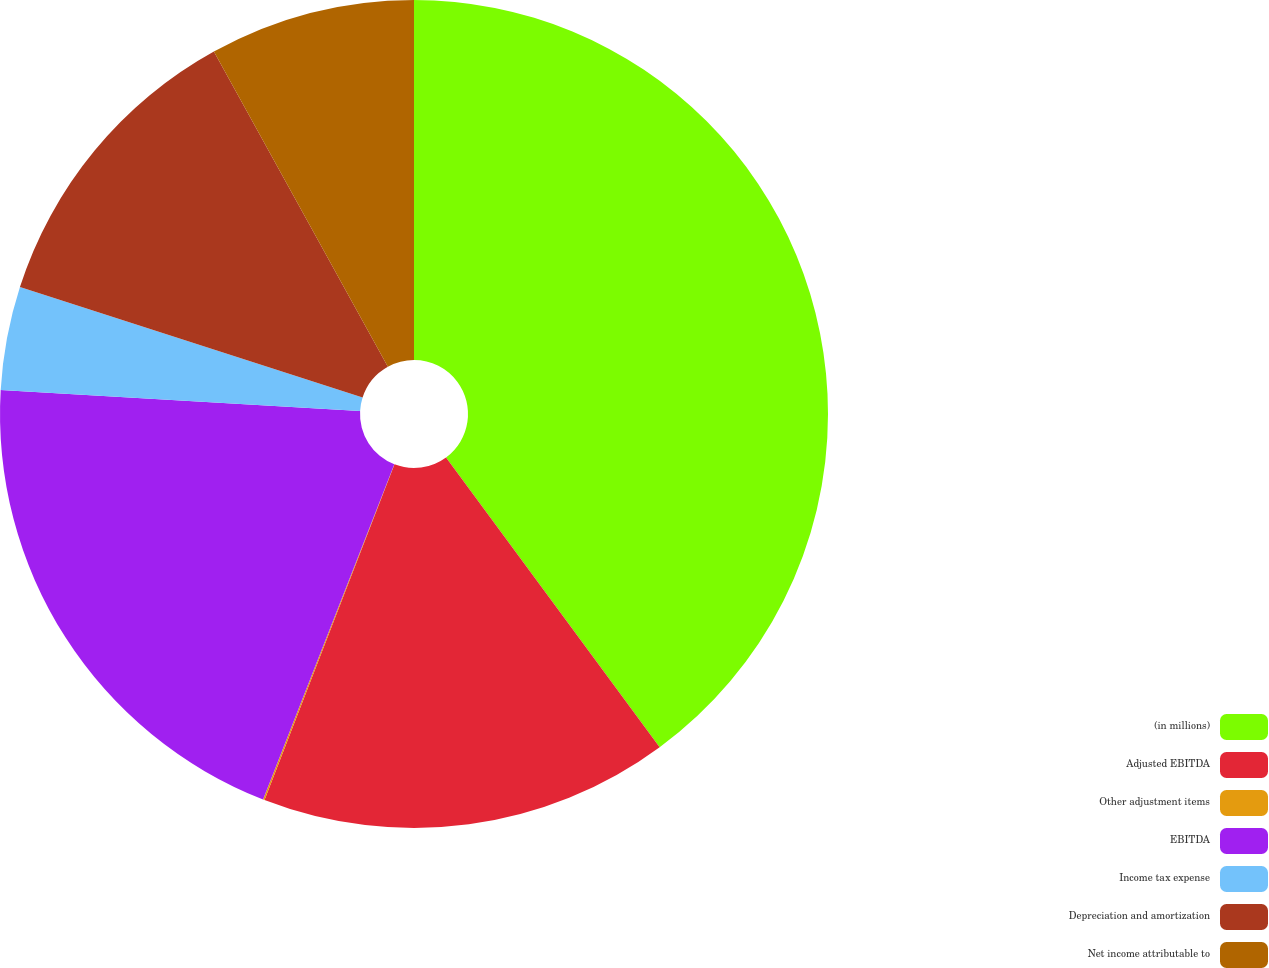<chart> <loc_0><loc_0><loc_500><loc_500><pie_chart><fcel>(in millions)<fcel>Adjusted EBITDA<fcel>Other adjustment items<fcel>EBITDA<fcel>Income tax expense<fcel>Depreciation and amortization<fcel>Net income attributable to<nl><fcel>39.89%<fcel>15.99%<fcel>0.06%<fcel>19.98%<fcel>4.04%<fcel>12.01%<fcel>8.03%<nl></chart> 